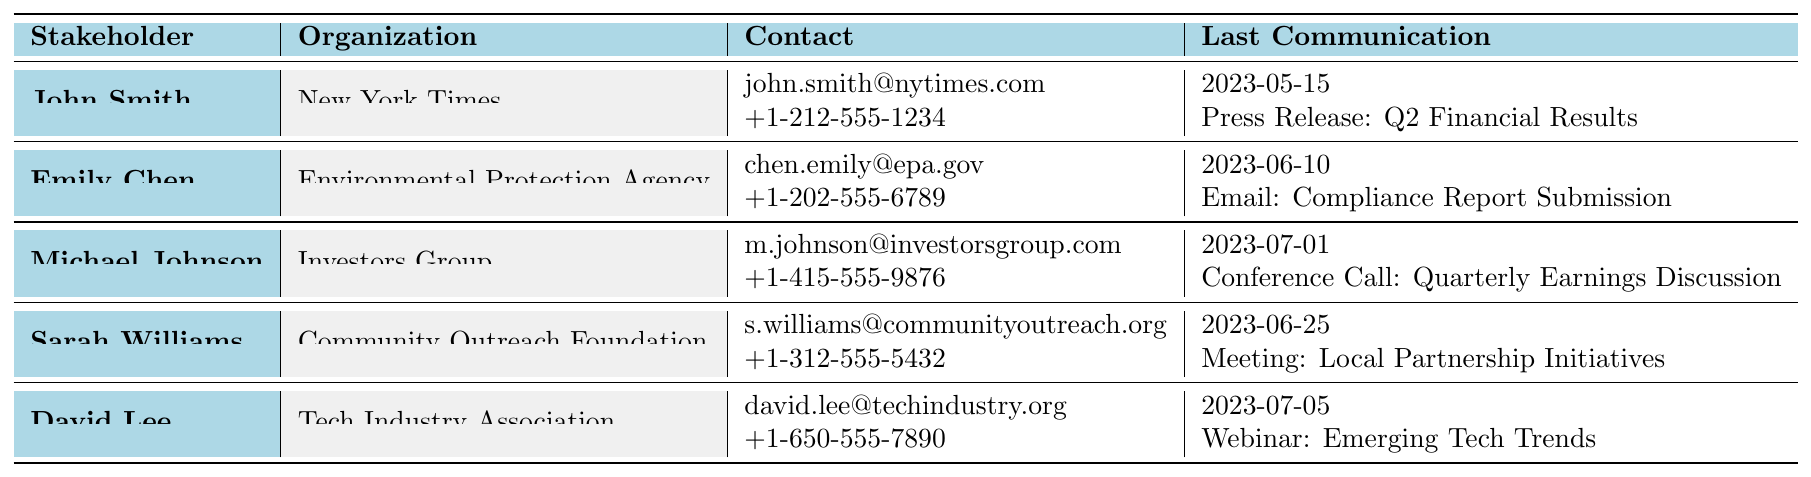What is the email address of David Lee? David Lee's email address is listed in the table under the contact information section. It reads "david.lee@techindustry.org".
Answer: david.lee@techindustry.org Who had a communication about the "Q2 Financial Results"? In the table, John Smith is noted as having a communication on May 15, 2023, with the subject "Q2 Financial Results".
Answer: John Smith Which stakeholder last communicated on June 10, 2023? By reviewing the last contact dates, Emily Chen shows the last communication date as June 10, 2023, which is clearly stated in the table.
Answer: Emily Chen How many stakeholders have had a meeting as part of their communication history? Counting the communication history shows that Emily Chen and Sarah Williams noted meetings in their histories, totaling two stakeholders who had meetings.
Answer: 2 What type of communication did Michael Johnson have on July 1, 2023? The table lists that Michael Johnson had a "Conference Call" on July 1, 2023, as part of his communication history.
Answer: Conference Call Is John Smith a reporter for the New York Times? The table confirms that John Smith is listed as a "Senior Reporter" for the "New York Times", indicating that the statement is true.
Answer: Yes List the roles of stakeholders who have communicated via email. The table shows that John Smith, Emily Chen, and Michael Johnson have had communications categorized as emails, with corresponding roles "Senior Reporter", "Public Affairs Specialist", and "Managing Director". This reveals three distinct roles.
Answer: 3 Which stakeholder had the earliest last contact date? By comparing the last contact dates in the table, John Smith's last contact is the earliest at May 15, 2023.
Answer: John Smith Did any stakeholders communicate with "Press Release" as part of their history? Looking at the communication history, John Smith and Sarah Williams both had communications noted as "Press Release". The information in the table answers this as true.
Answer: Yes What is the average number of times stakeholders have communicated based on the given history? There is a total of 10 communication entries across 5 stakeholders, which gives an average of 10 / 5 = 2 communications per stakeholder.
Answer: 2 